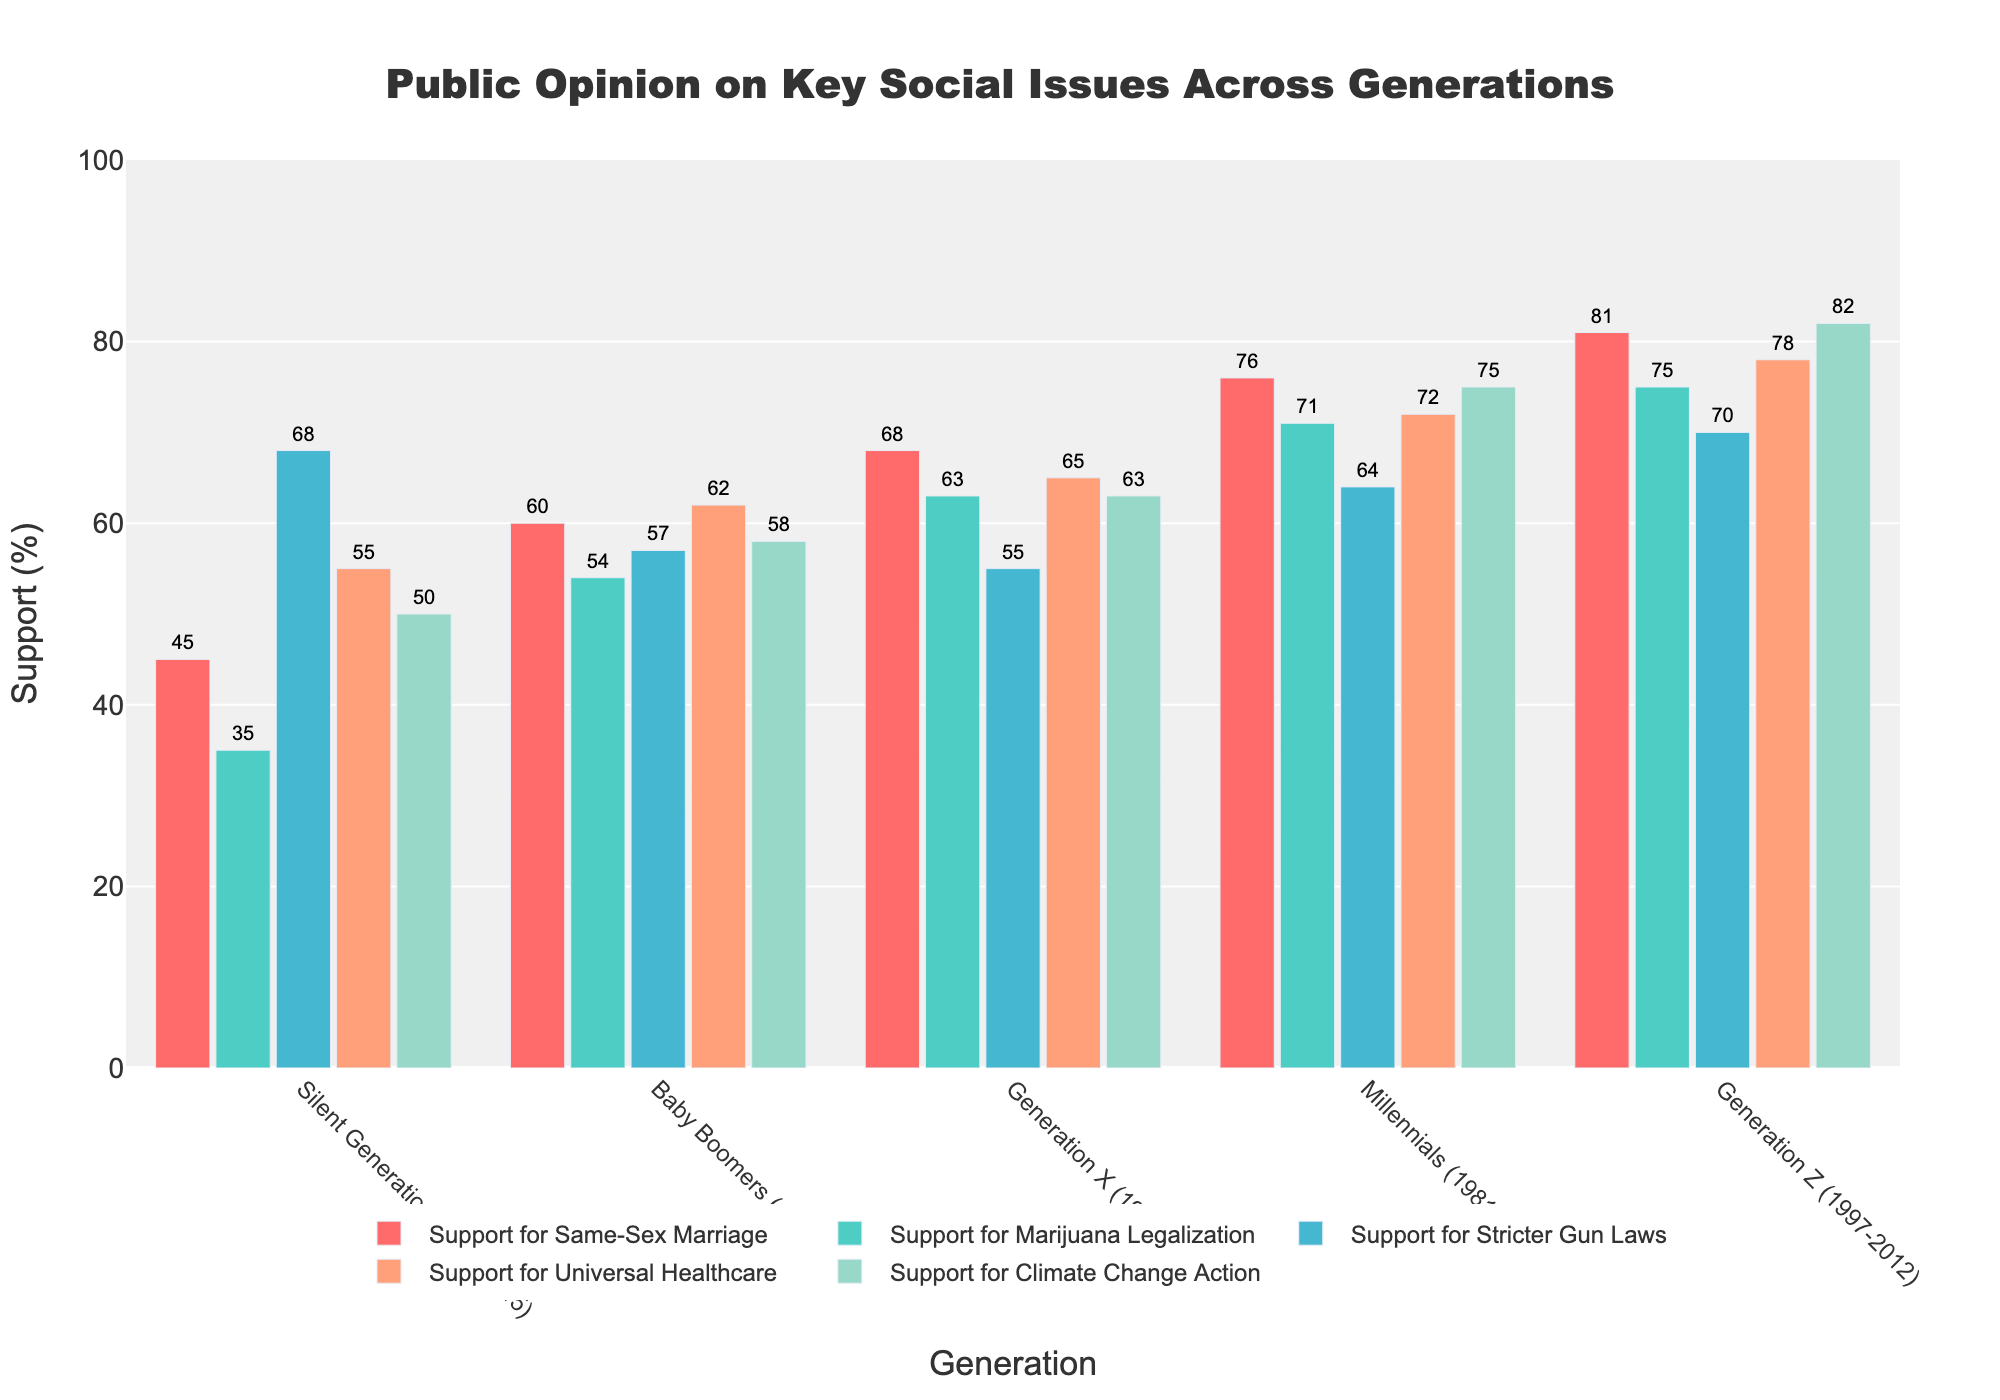Which generation shows the highest support for Universal Healthcare? To find the generation with the highest support for Universal Healthcare, look for the tallest bar in the 'Support for Universal Healthcare' category. Generation Z's bar is the tallest at 78%.
Answer: Generation Z Which two generations have the closest percentage in support for Climate Change Action? Compare the heights of the bars representing 'Support for Climate Change Action' across different generations to find the closest values. The closest percentages are for Generation X (63%) and Baby Boomers (58%), with a difference of 5%.
Answer: Generation X and Baby Boomers Which social issue receives the least support from the Baby Boomers generation? Look at the bars for the Baby Boomers across all social issues. The shortest bar is 'Support for Marijuana Legalization' at 54%.
Answer: Support for Marijuana Legalization What is the difference in support for Same-Sex Marriage between the Silent Generation and Generation Z? Subtract the support percentage of Same-Sex Marriage for the Silent Generation from that of Generation Z. Generation Z has 81%, and the Silent Generation has 45%, so the difference is 81% - 45% = 36%.
Answer: 36% Between Millennials and Generation X, which generation has a higher support percentage for Stricter Gun Laws and by how much? Compare the bars for 'Support for Stricter Gun Laws' between Millennials (64%) and Generation X (55%). The difference is 64% - 55% = 9%.
Answer: Millennials by 9% Which generation shows the least variation in their support percentages across all social issues? Look at the range of bar heights for each generation. Generation X's bars (55% - 68%) have the smallest range of 13 percentage points, indicating the least variation.
Answer: Generation X What is the sum of support percentages for Marijuana Legalization and Stricter Gun Laws for Millennials? Add the support percentages of 'Support for Marijuana Legalization' (71%) and 'Support for Stricter Gun Laws' (64%). The sum is 71% + 64% = 135%.
Answer: 135% For which social issue is the difference in support between the Silent Generation and Baby Boomers the largest? Calculate the differences in support percentages for each social issue between these generations and identify the largest difference. The 'Support for Marijuana Legalization' has the biggest difference of 54% - 35% = 19%.
Answer: Support for Marijuana Legalization How many generations have more than 70% support for Climate Change Action? Identify the bars where 'Support for Climate Change Action' exceeds 70%. Millennials (75%) and Generation Z (82%) have more than 70%.
Answer: 2 generations What is the average support for Same-Sex Marriage across all generations? Add the percentages of 'Support for Same-Sex Marriage' across all generations and divide by the number of generations. (45 + 60 + 68 + 76 + 81) / 5 = 330 / 5 = 66%.
Answer: 66% 